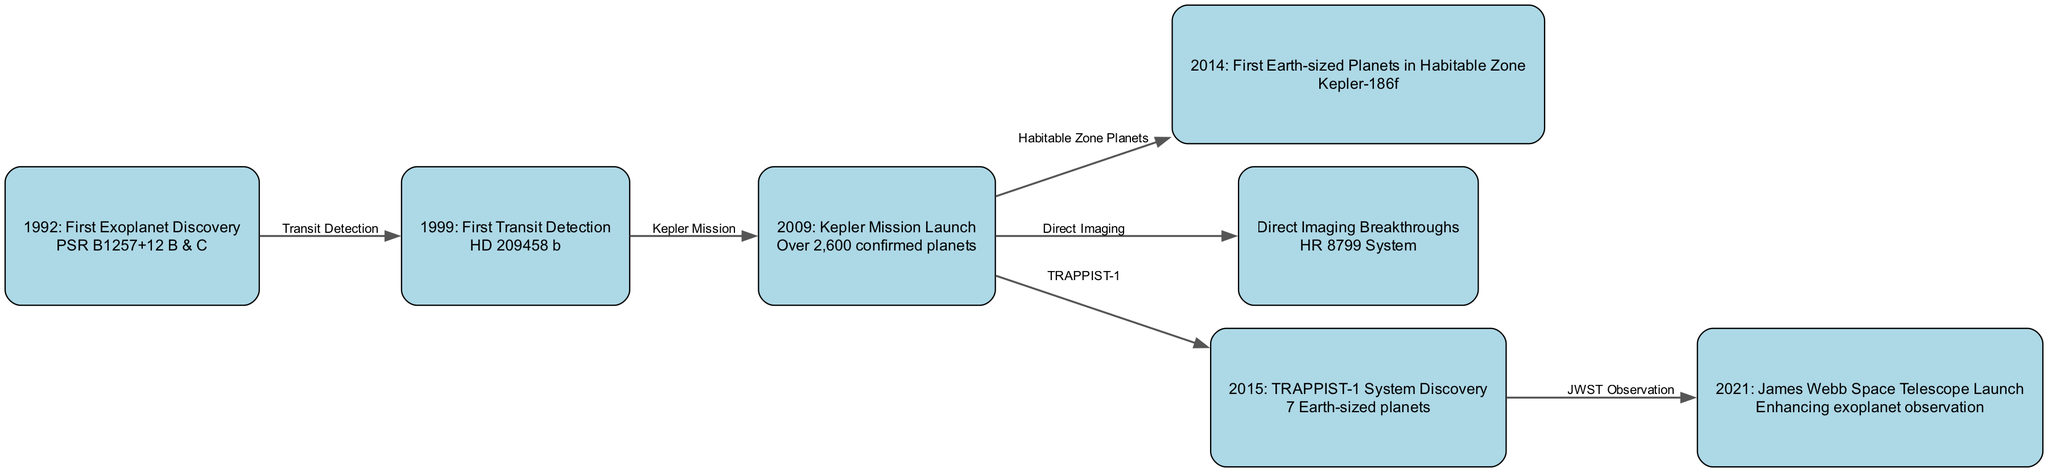What year did the first exoplanet get discovered? According to the diagram, the first exoplanet was discovered in 1992. This is represented as the first node with the label "1992: First Exoplanet Discovery".
Answer: 1992 How many Earth-sized planets were found in the TRAPPIST-1 system? The diagram indicates that the TRAPPIST-1 system contains 7 Earth-sized planets. This information is included in the node labeled "2015: TRAPPIST-1 System Discovery".
Answer: 7 What significant mission was launched in 2009? The diagram shows that the Kepler Mission was launched in 2009, as indicated in the node labeled "2009: Kepler Mission Launch". This mission is critical for the discovery of many exoplanets.
Answer: Kepler Mission Which exoplanet is associated with the first transit detection? The diagram associates HD 209458 b with the first transit detection, as represented in the node labeled "1999: First Transit Detection". This highlights an important milestone in exoplanet study.
Answer: HD 209458 b What connection exists between the Kepler Mission and Earth-sized planets? The diagram shows an edge labeled "Habitable Zone Planets" connecting the Kepler Mission (2009) node to the Earth-sized planets (2014), indicating that the mission contributed to the discovery of planets in the habitable zone, exemplified by Kepler-186f.
Answer: Habitable Zone Planets What does the edge labeled "Direct Imaging" represent? The edge labeled "Direct Imaging" interconnects the 2009 Kepler Mission to the breakthroughs in Direct Imaging, indicating a progression in observation techniques enabled by the Kepler Mission that led to being able to directly image exoplanets.
Answer: Direct Imaging What role does the James Webb Space Telescope serve in exoplanet observation? The diagram specifies that the James Webb Space Telescope enhances exoplanet observation, as shown in the node for its launch in 2021. This telescope represents an important advancement in the study of exoplanets.
Answer: Enhancing exoplanet observation Which system is highlighted for breakthroughs in direct imaging? The diagram highlights the HR 8799 System as the key example of breakthrough in direct imaging techniques, which is represented in the node labeled "Direct Imaging Breakthroughs".
Answer: HR 8799 System What is the overall theme of the diagram? The overall theme centers around the timeline and key milestones related to the discovery of exoplanets, including significant contributions from various missions and advances in photographic techniques.
Answer: Exoplanet Discovery Timeline 